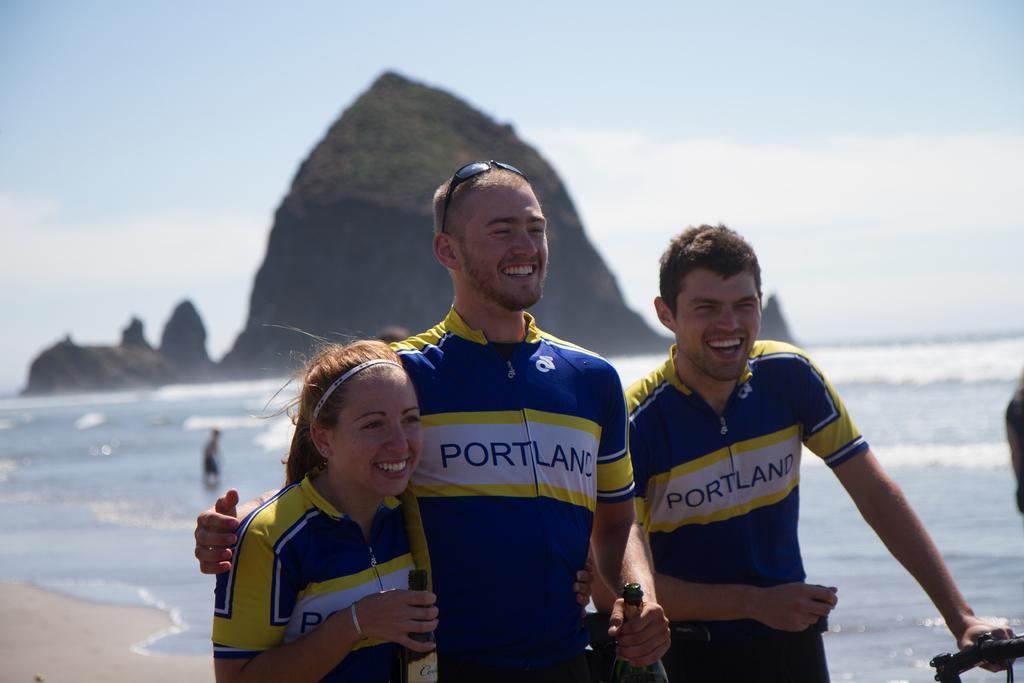<image>
Create a compact narrative representing the image presented. THREE PEOPLE STANDING ON THE BEACH WITH PORTLAND WRITTEN ON THEIR SHIRTS 